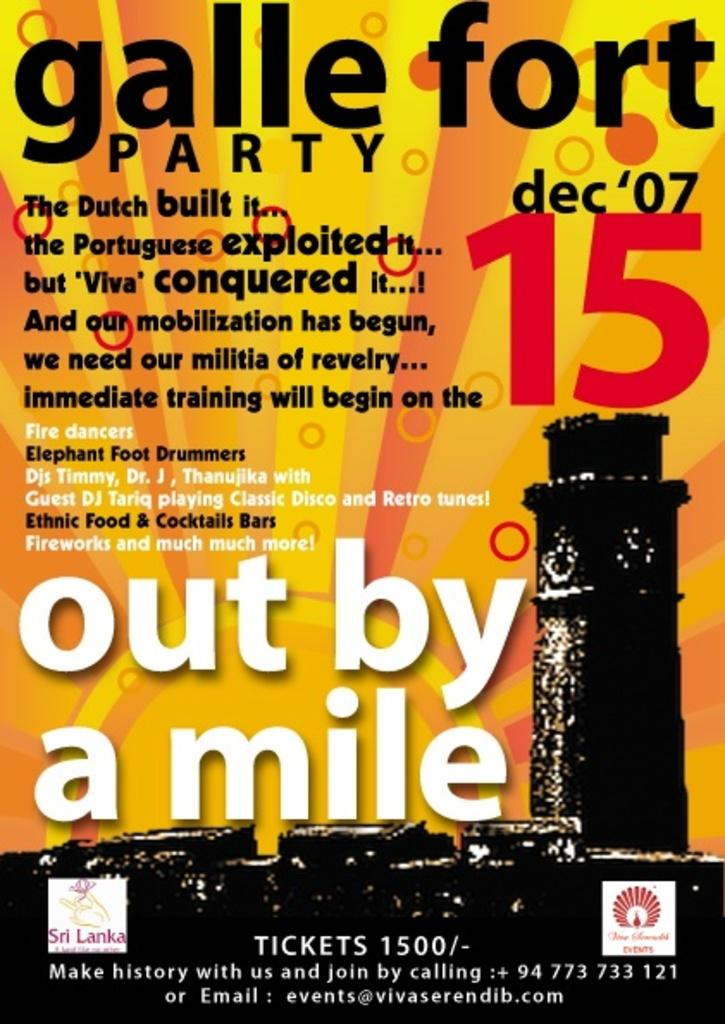<image>
Summarize the visual content of the image. A poster that read galle fort party dec 07' 15. 